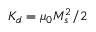Convert formula to latex. <formula><loc_0><loc_0><loc_500><loc_500>K _ { d } = \mu _ { 0 } M _ { s } ^ { 2 } / 2</formula> 